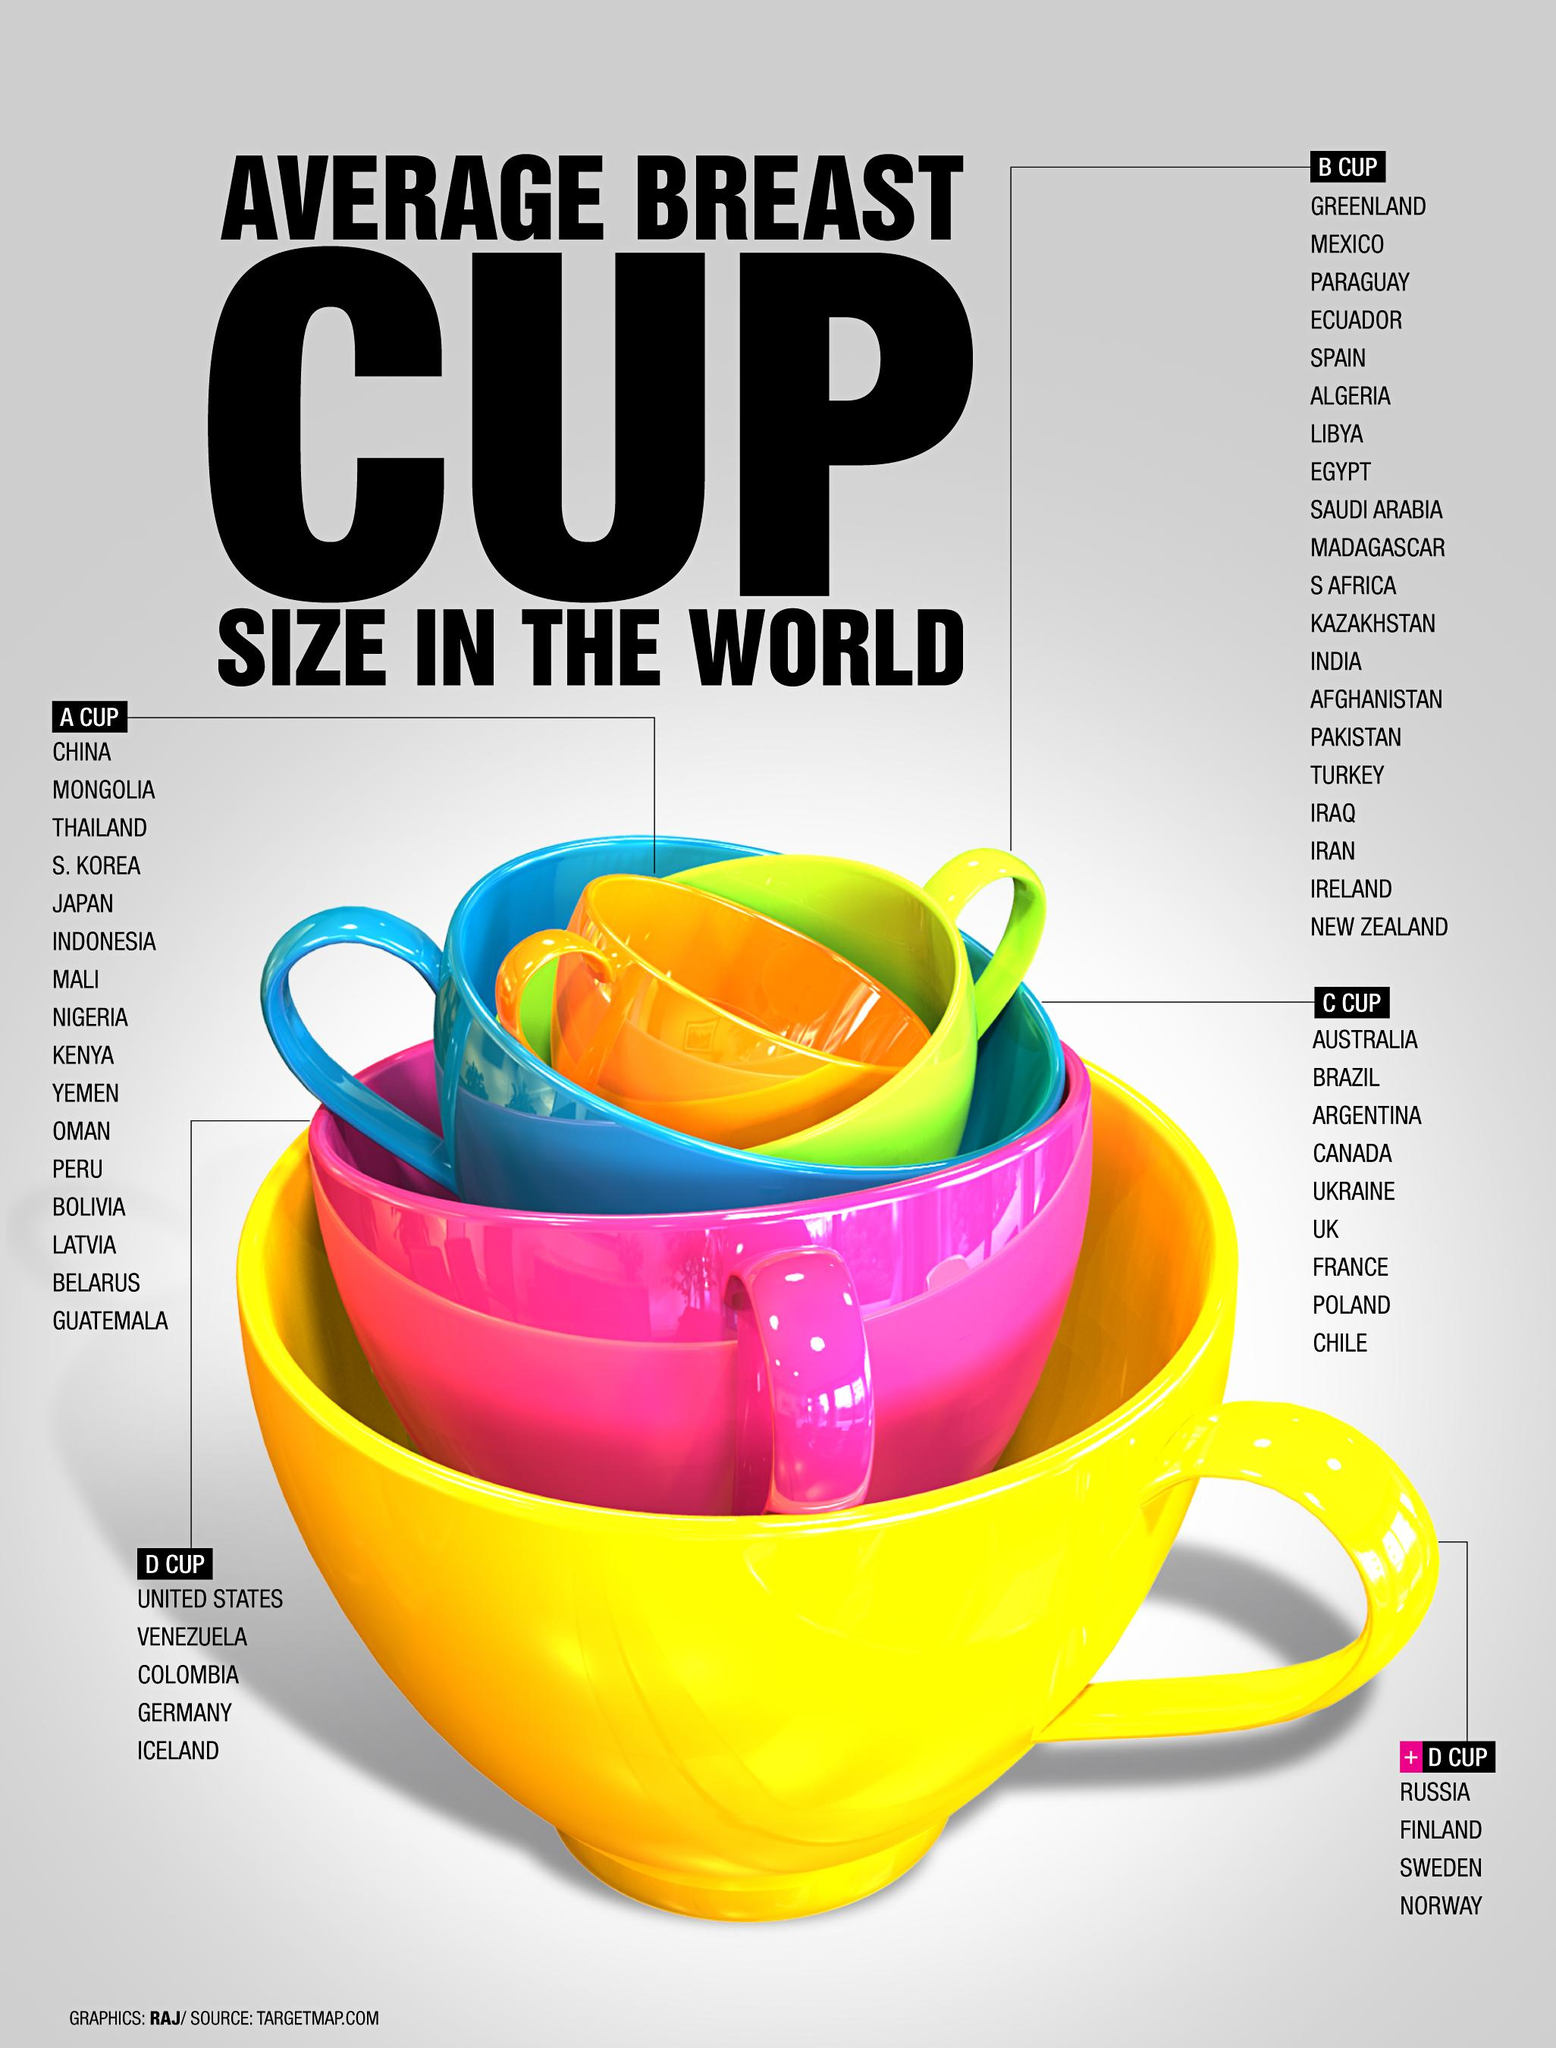Indicate a few pertinent items in this graphic. The blue cup represents the cup size of 9 countries. The color of the cup in the image is orange, representing the size A- category. Pakistan is categorized as a B cup size. The pink cup in the image is representative of the size D cup. Finland is the second country listed under the cup size represented by the yellow cup. 